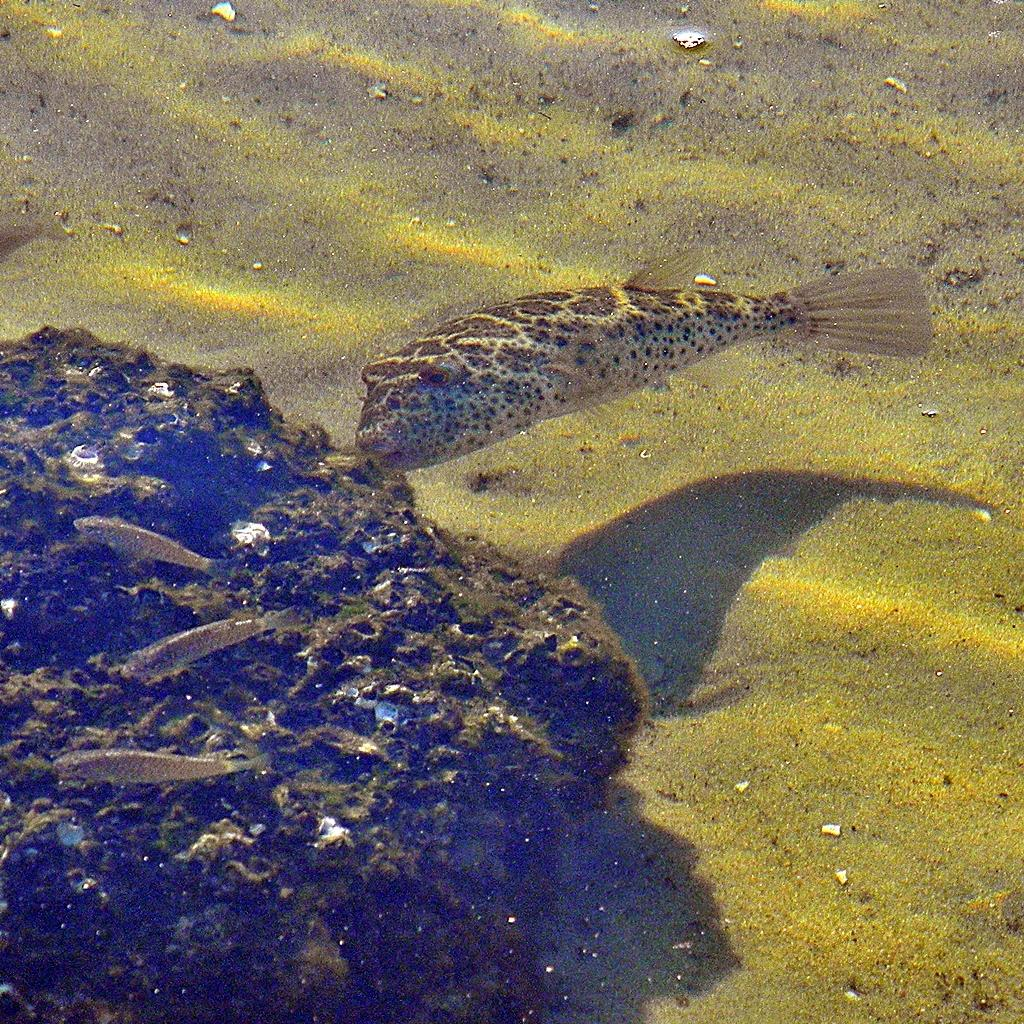What type of animals can be seen in the image? There are fishes in the water. What is at the bottom of the water? There is sand at the bottom of the water. What else can be found in the water besides fishes? There are plants in the water. Where are the horses swimming in the image? There are no horses present in the image. Can you describe the icicle hanging from the plants in the image? There are no icicles present in the image; it features fishes, sand, and plants in the water. 